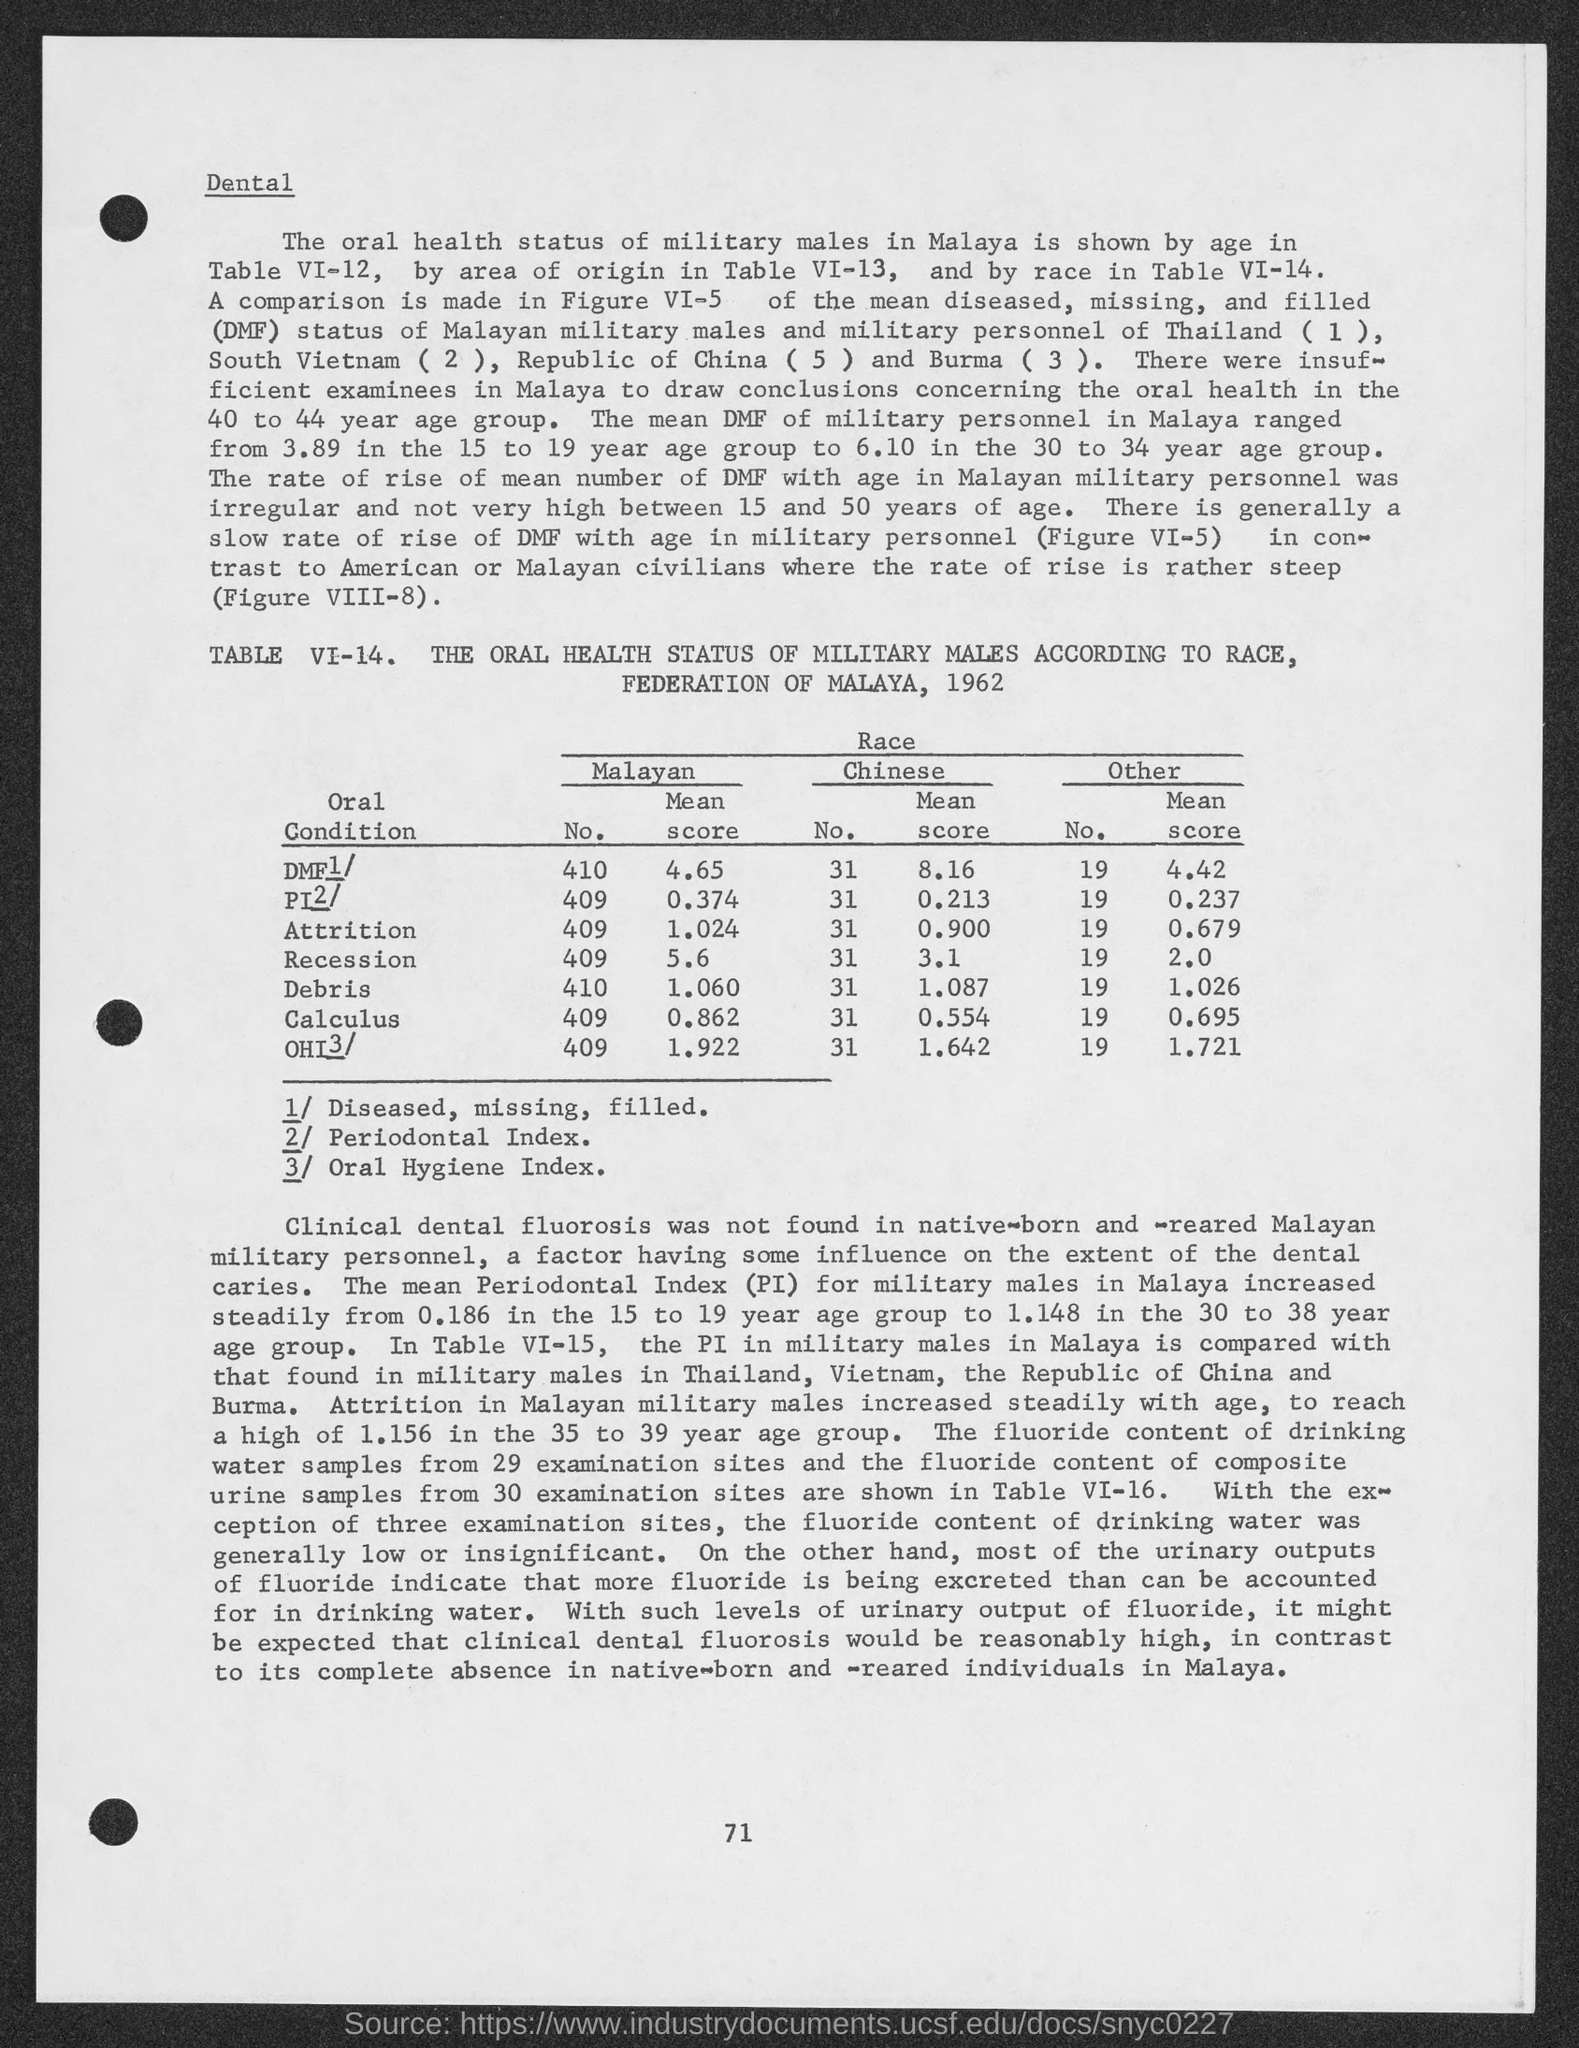What is the number at bottom of the page ?
Offer a very short reply. 71. What is the malayan mean score for attrition?
Your response must be concise. 1.024. What is the malayan mean score for recession ?
Your answer should be very brief. 5.6. What is the malayan mean score for debris ?
Provide a succinct answer. 1.060. What is the malayan mean score for calculus ?
Your answer should be compact. 0.862. What is the chinese mean score for attrition ?
Your response must be concise. 0.900. What is the chinese mean score for recession ?
Offer a very short reply. 3.1. What is the chinese mean score for debris ?
Offer a terse response. 1.087. What is the chinese mean score for calculus ?
Your response must be concise. 0.554. What is the other mean score for attrition ?
Your answer should be very brief. 0.679. 